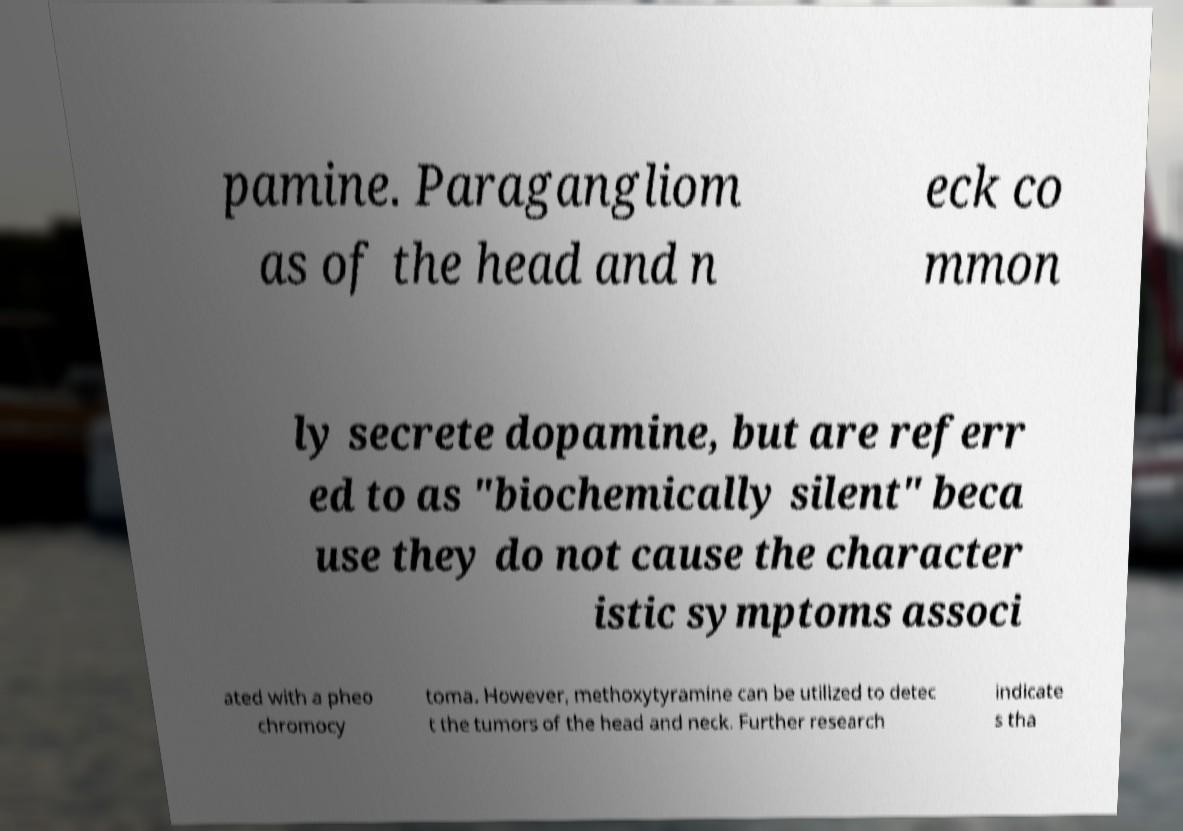Please identify and transcribe the text found in this image. pamine. Paragangliom as of the head and n eck co mmon ly secrete dopamine, but are referr ed to as "biochemically silent" beca use they do not cause the character istic symptoms associ ated with a pheo chromocy toma. However, methoxytyramine can be utilized to detec t the tumors of the head and neck. Further research indicate s tha 